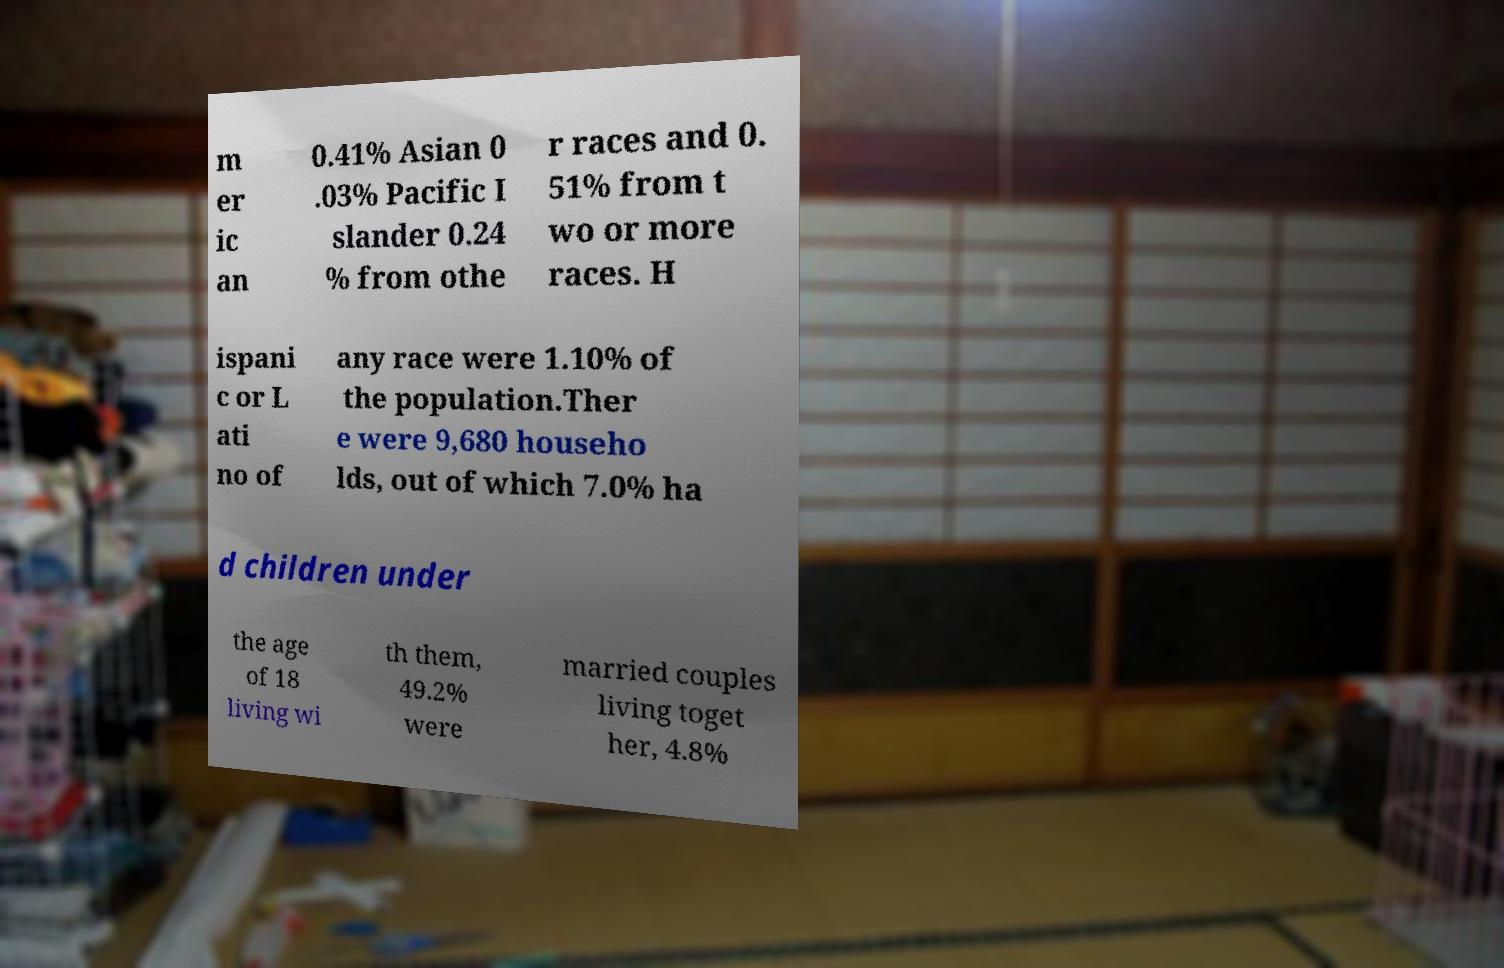I need the written content from this picture converted into text. Can you do that? m er ic an 0.41% Asian 0 .03% Pacific I slander 0.24 % from othe r races and 0. 51% from t wo or more races. H ispani c or L ati no of any race were 1.10% of the population.Ther e were 9,680 househo lds, out of which 7.0% ha d children under the age of 18 living wi th them, 49.2% were married couples living toget her, 4.8% 